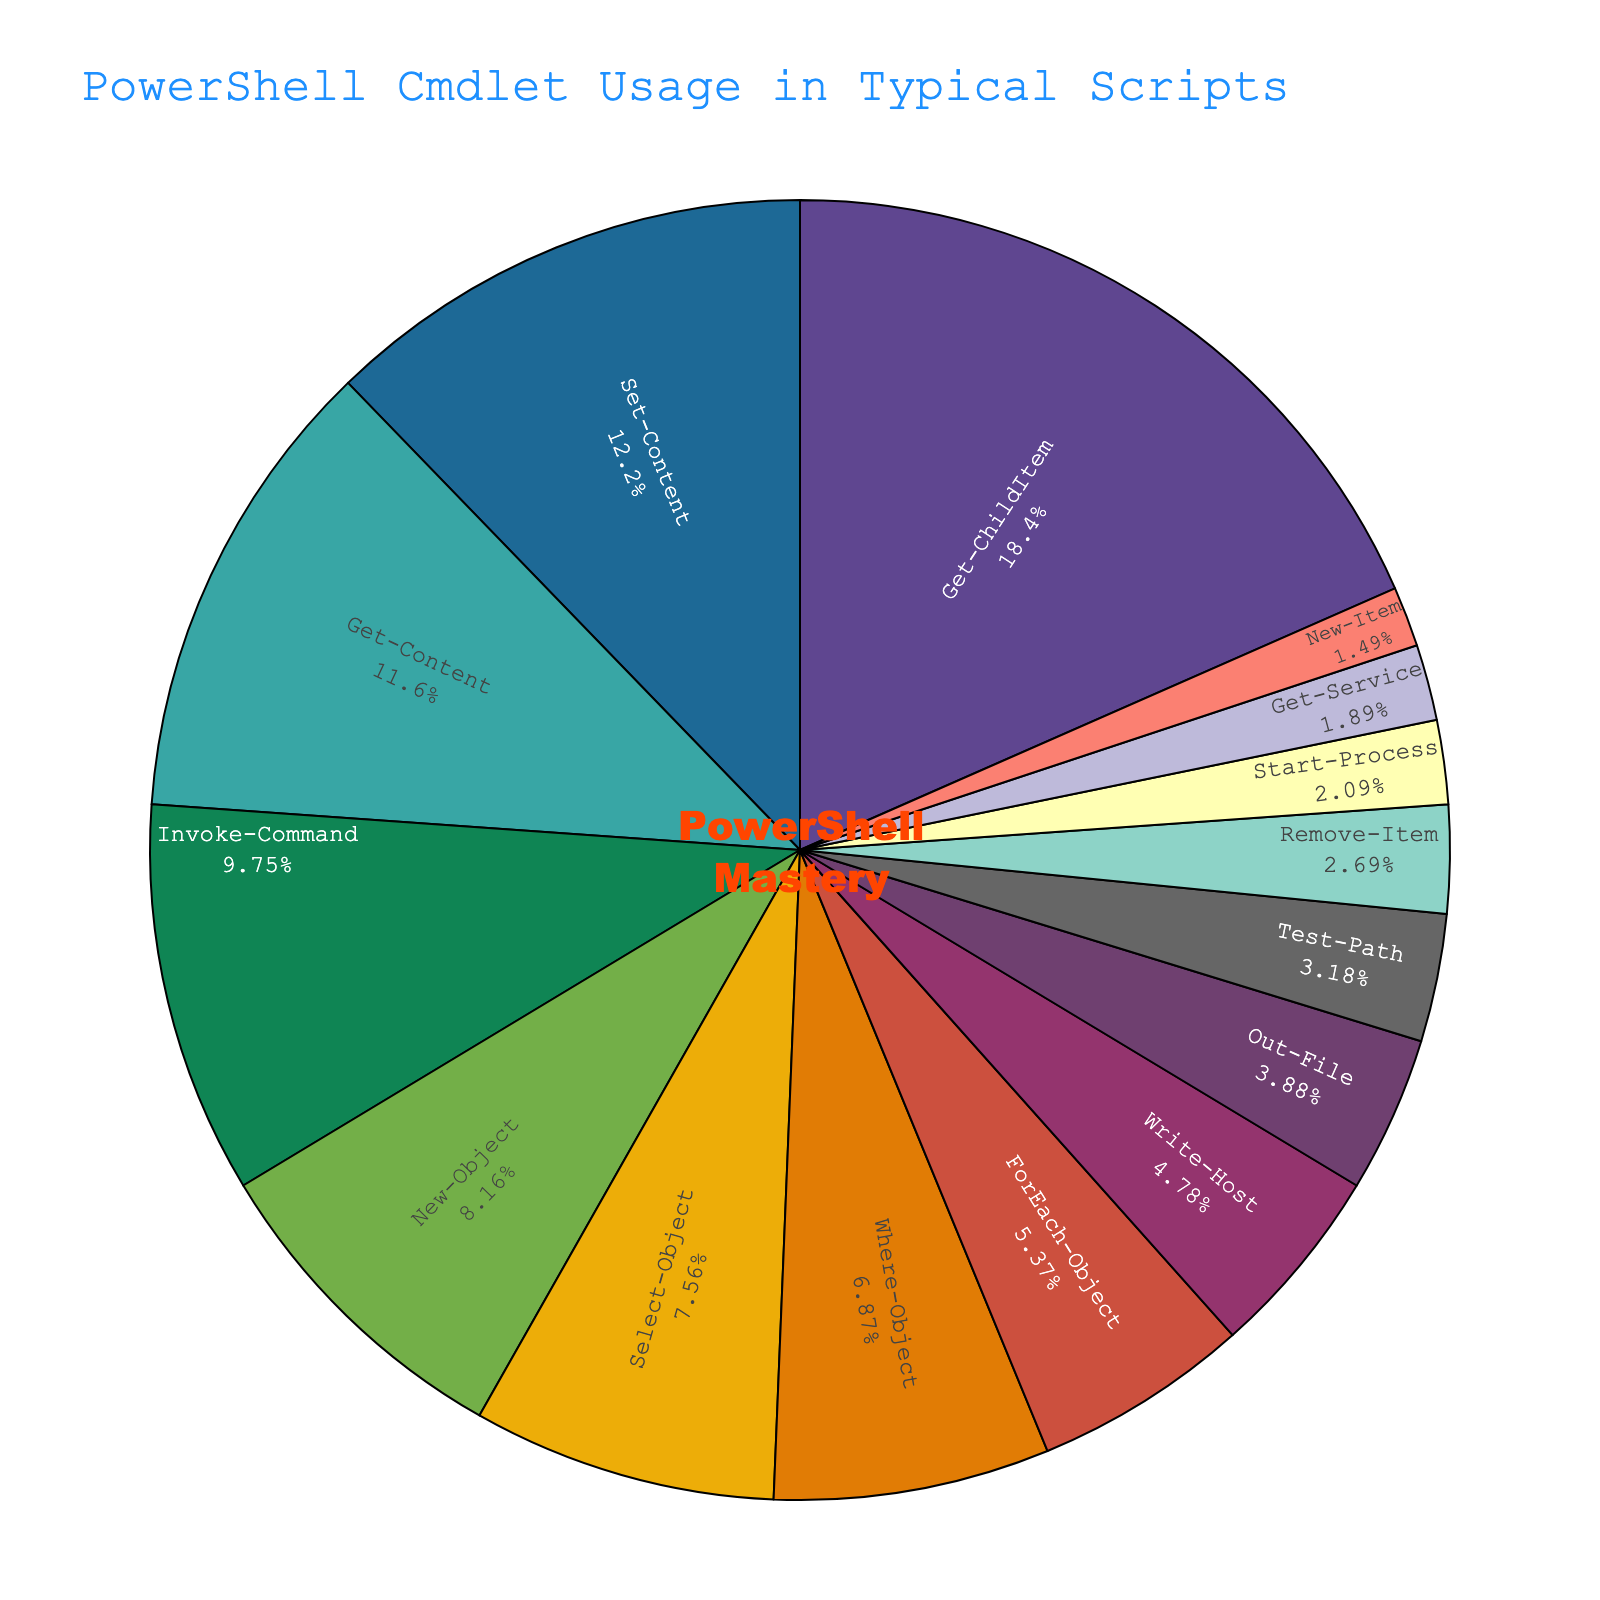What is the most frequently used cmdlet in this script? The pie chart shows the usage percentages of various PowerShell cmdlets, with each sector representing one cmdlet. The cmdlet "Get-ChildItem" has the largest sector, indicating it is the most frequently used.
Answer: Get-ChildItem Which cmdlet is used more frequently: New-Object or Set-Content? By looking at the pie chart, we see the sectors showing the usage percentage of New-Object and Set-Content. Set-Content has a higher usage percentage (12.3%) compared to New-Object (8.2%).
Answer: Set-Content What is the combined usage percentage of Get-Content and Invoke-Command? From the pie chart, Get-Content has a usage percentage of 11.7% and Invoke-Command has 9.8%. Adding these together gives 11.7% + 9.8% = 21.5%.
Answer: 21.5% Which cmdlet has a lower usage percentage: Remove-Item or Test-Path? The pie chart shows the usage percentage of both Remove-Item and Test-Path. Remove-Item is at 2.7% while Test-Path is at 3.2%, so Remove-Item has a lower usage percentage.
Answer: Remove-Item How much more frequently is Write-Host used compared to Out-File? Write-Host has a usage percentage of 4.8% while Out-File has 3.9%. The difference is 4.8% - 3.9% = 0.9%.
Answer: 0.9% Which cmdlet usage is closest to 10%? The cmdlet closest to 10% is Invoke-Command, which has a usage percentage of 9.8%.
Answer: Invoke-Command Is the combined usage of Start-Process and Remove-Item greater than 5%? The combined usage percentage of Start-Process (2.1%) and Remove-Item (2.7%) is 2.1% + 2.7% = 4.8%, which is less than 5%.
Answer: No Which cmdlet's sector in the pie chart is located between the usages of Write-Host and Out-File? By observing the pie chart, the cmdlet sector located between Write-Host (4.8%) and Out-File (3.9%) is ForEach-Object with a percentage of 5.4%.
Answer: ForEach-Object How many cmdlets have a usage percentage greater than 5% and less than 10%? Visually identifying the sectors in the range of greater than 5% and less than 10%: ForEach-Object (5.4%), Where-Object (6.9%), Select-Object (7.6%), and New-Object (8.2%) meet the criteria. This makes a total of 4 cmdlets.
Answer: 4 